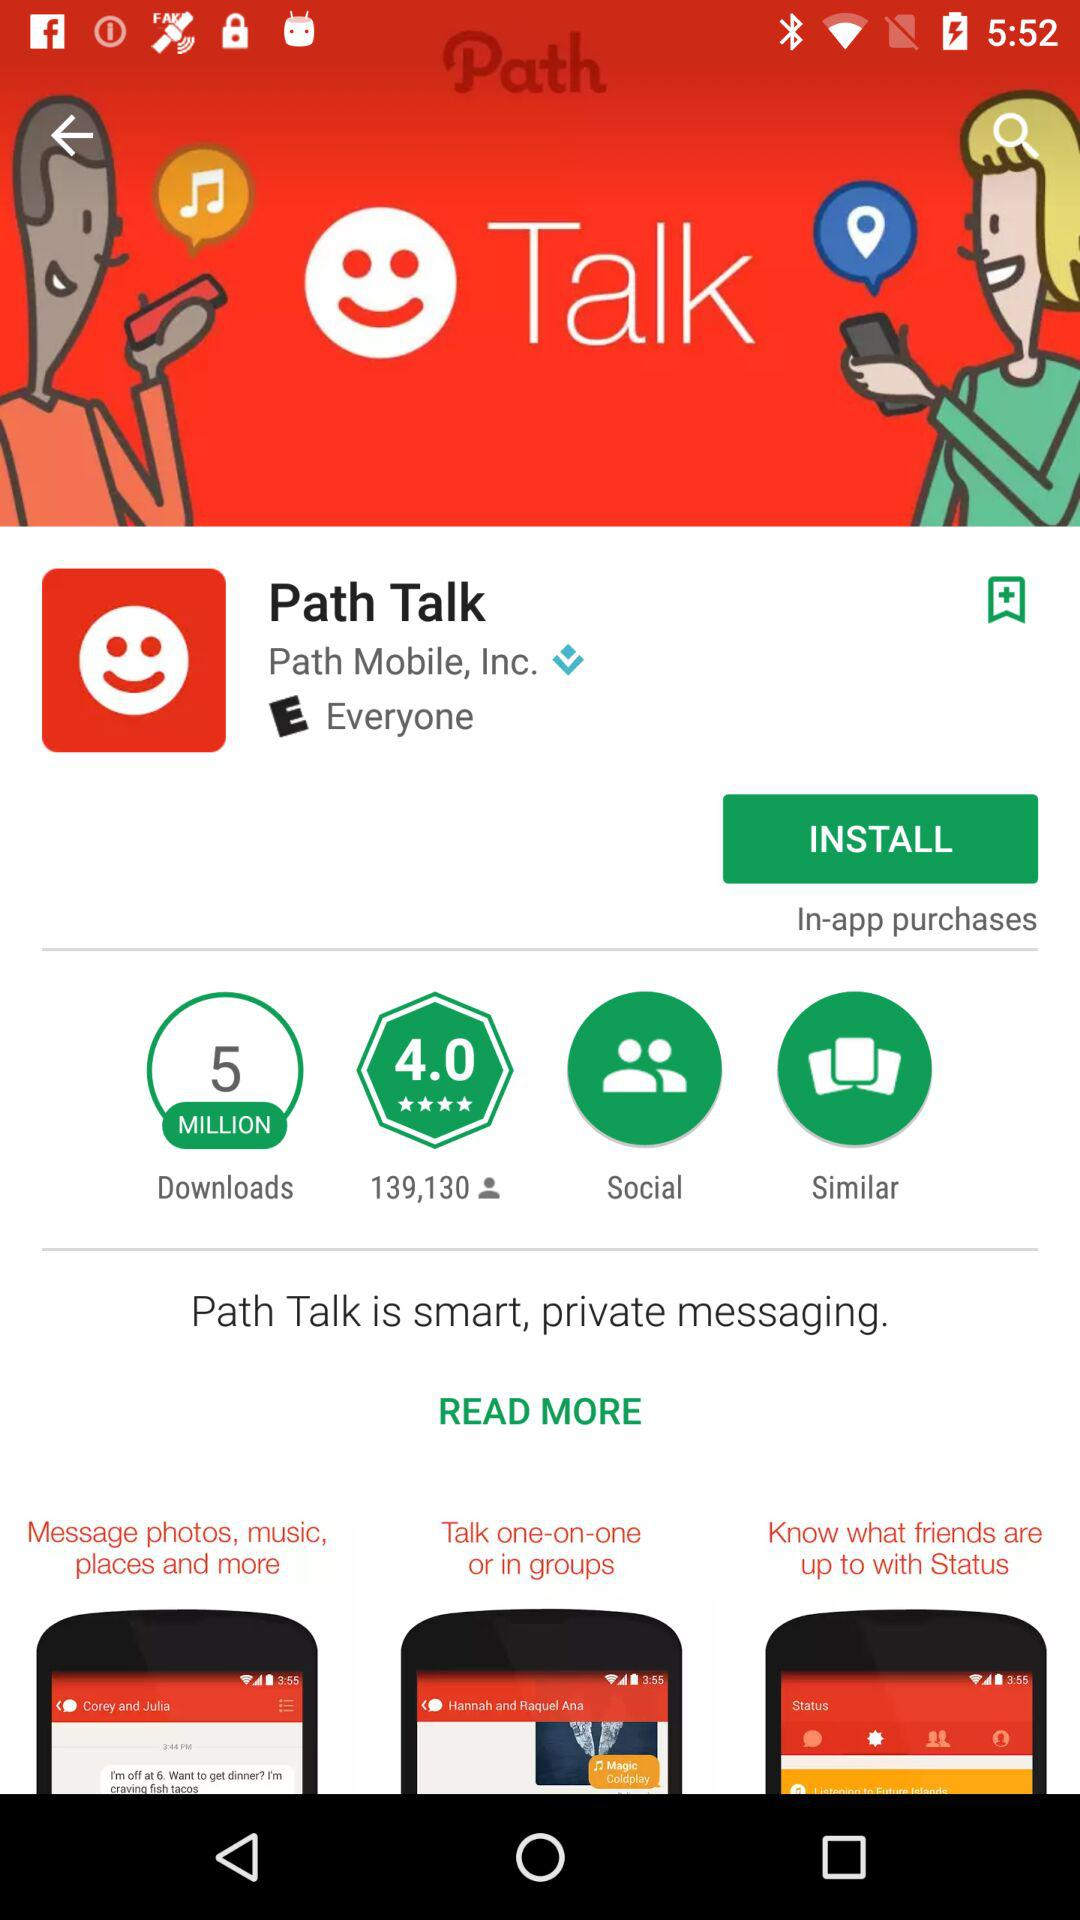What is the rating of this app?
Answer the question using a single word or phrase. The rating is 4.0 